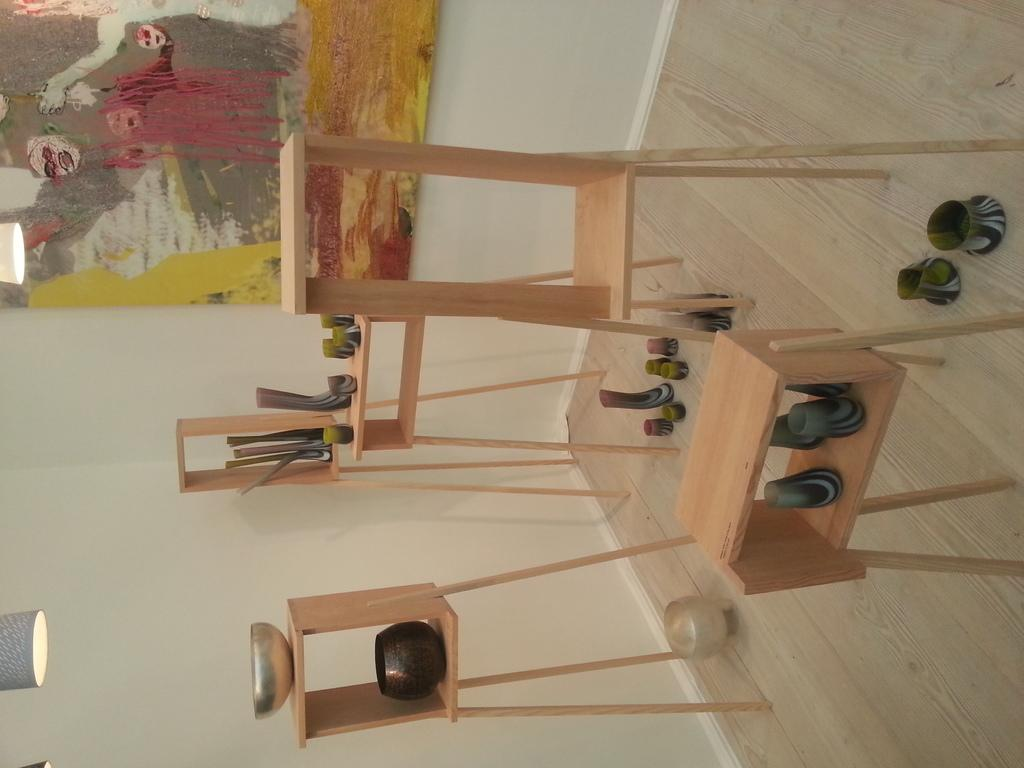What type of furniture is present in the image? There are wooden tables in the image. What can be found on top of the wooden tables? There are objects on the wooden tables. What is the frame in the image like? The frame in the image is colorful. Where is the colorful frame located? The colorful frame is attached to a white wall. What type of bell can be heard ringing in the image? There is no bell present in the image, and therefore no sound can be heard. 